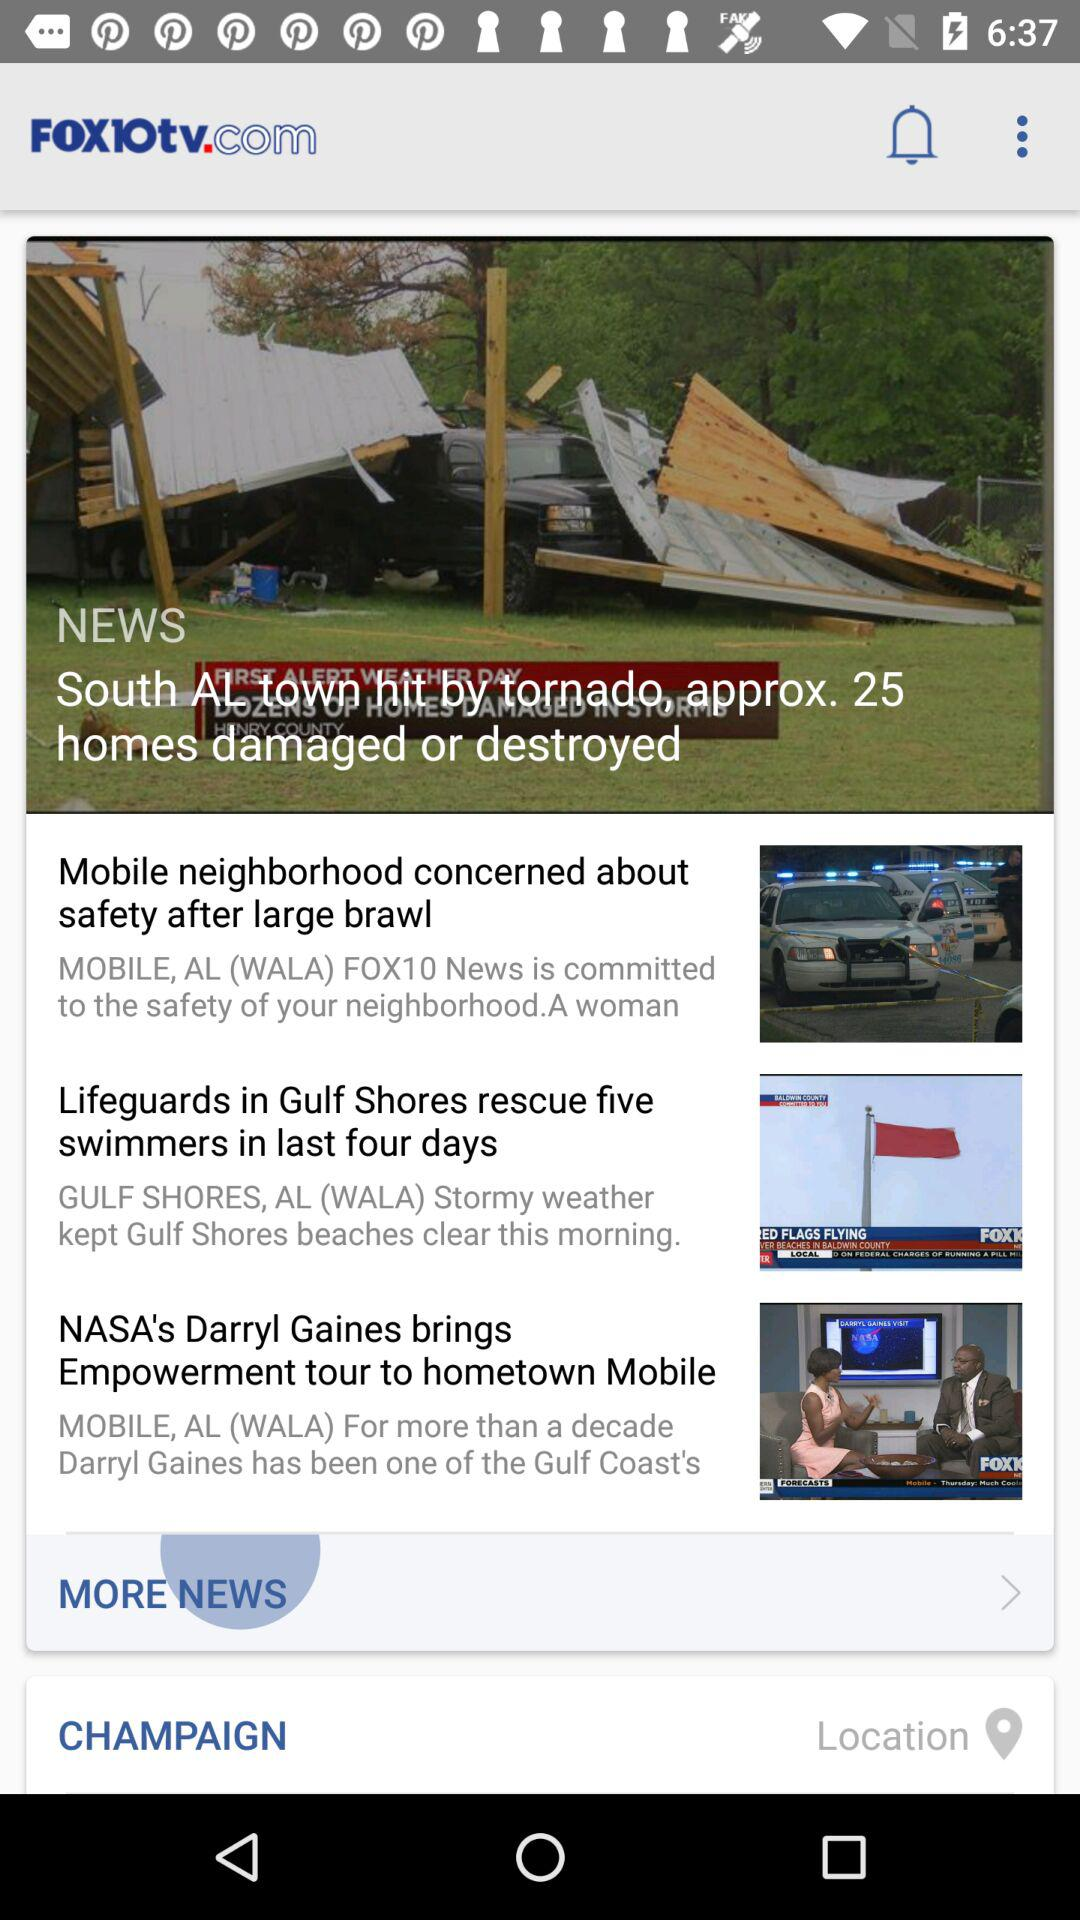How many homes are damaged or destroyed in the South AL town? There are approximately 25 homes damaged or destroyed in the South AL town. 